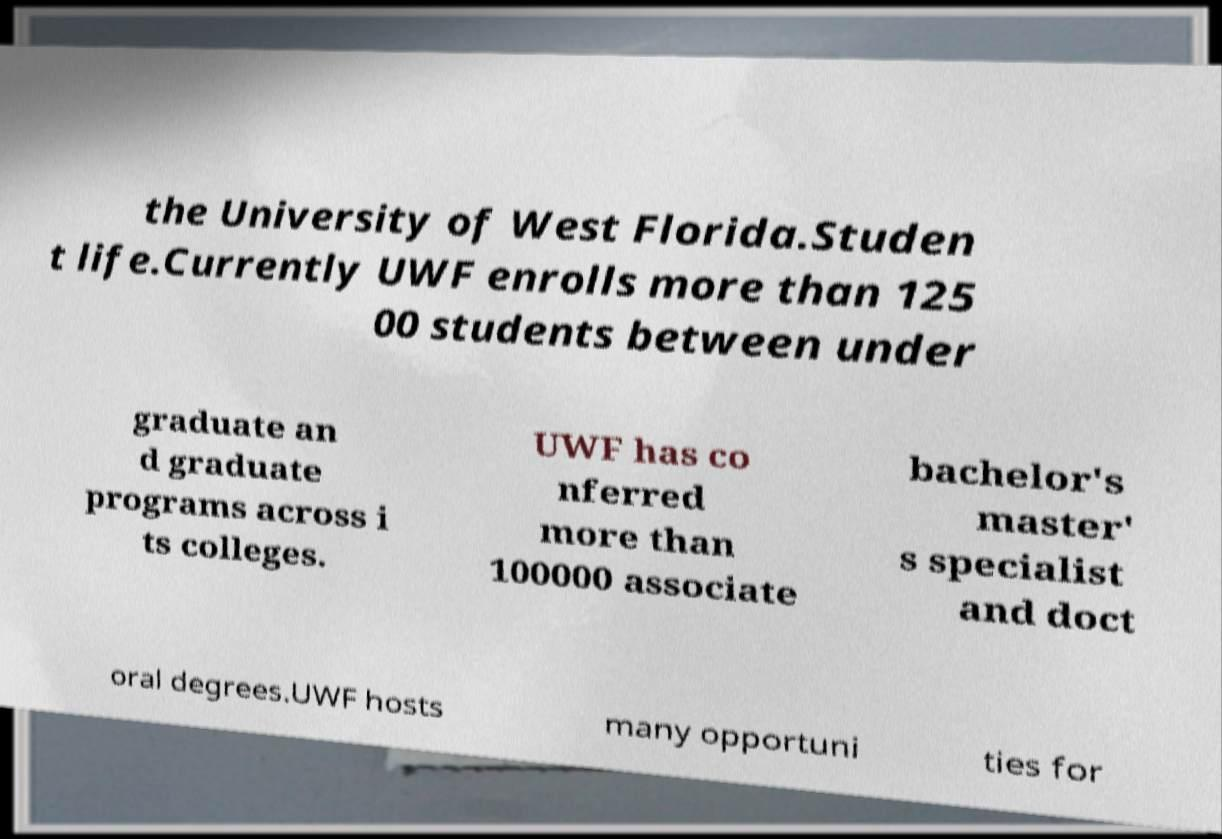I need the written content from this picture converted into text. Can you do that? the University of West Florida.Studen t life.Currently UWF enrolls more than 125 00 students between under graduate an d graduate programs across i ts colleges. UWF has co nferred more than 100000 associate bachelor's master' s specialist and doct oral degrees.UWF hosts many opportuni ties for 